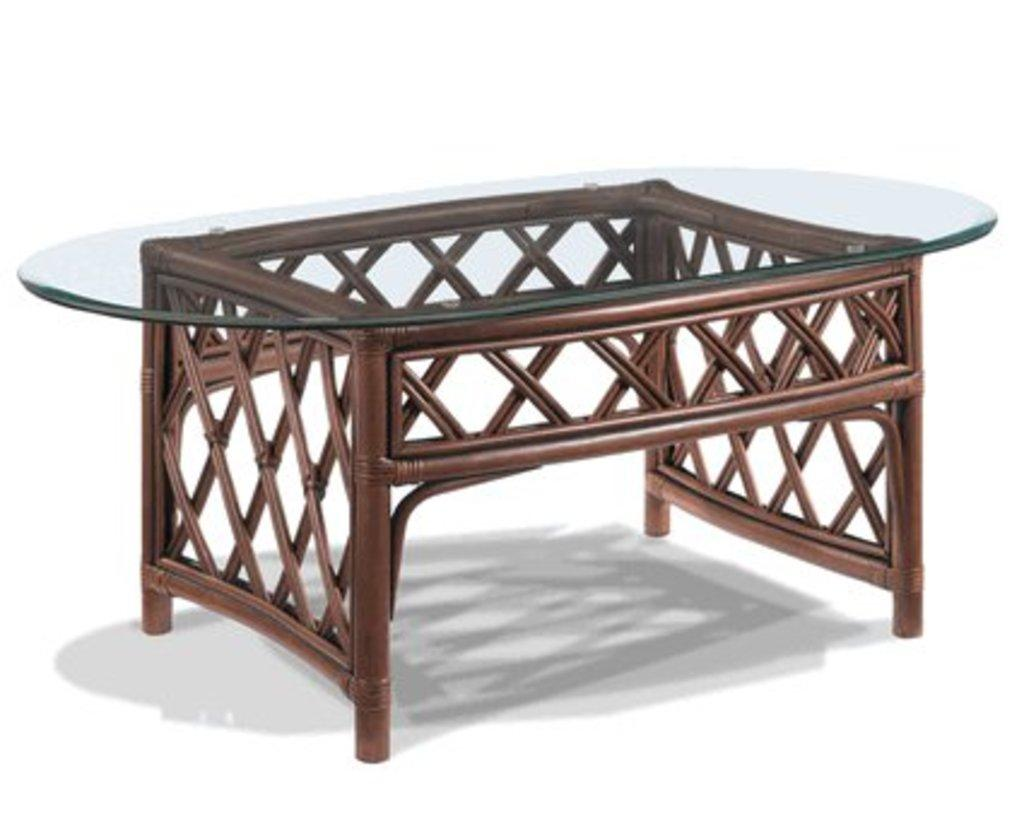What type of table is visible in the image? There is a glass table in the image. What is the surface beneath the glass table? The glass table is on a white surface. What color dominates the background of the image? The background of the image is in white color. Can you see any trails left by lizards in the image? There are no lizards or trails visible in the image. 